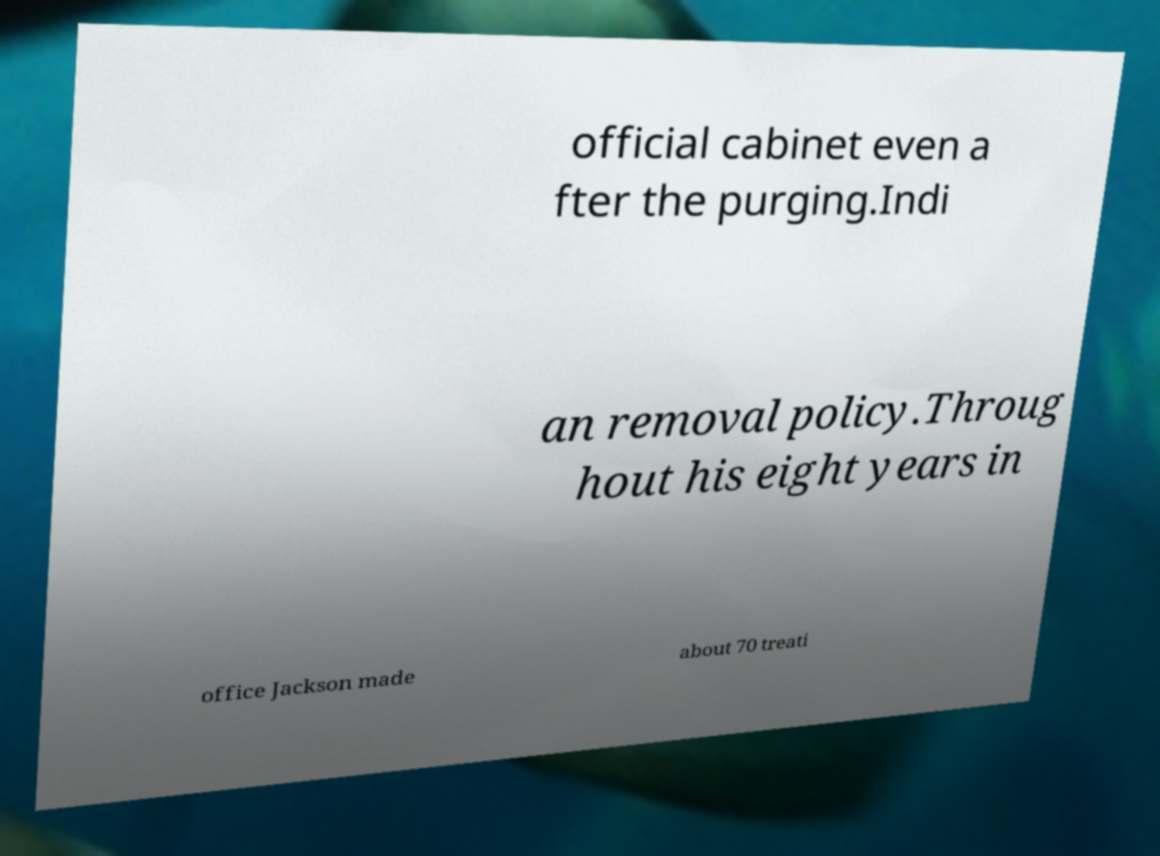Can you accurately transcribe the text from the provided image for me? official cabinet even a fter the purging.Indi an removal policy.Throug hout his eight years in office Jackson made about 70 treati 